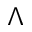<formula> <loc_0><loc_0><loc_500><loc_500>\Lambda</formula> 